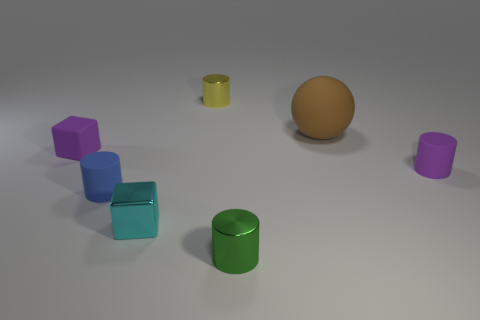Are there more brown matte objects than large cyan metal balls?
Your answer should be very brief. Yes. There is a cylinder that is in front of the tiny purple cube and behind the small blue object; how big is it?
Give a very brief answer. Small. What shape is the large thing?
Make the answer very short. Sphere. Is there anything else that is the same size as the purple cylinder?
Keep it short and to the point. Yes. Is the number of tiny blocks that are behind the tiny yellow metallic object greater than the number of small metal cylinders?
Your answer should be compact. No. What is the shape of the small rubber thing on the right side of the brown sphere that is right of the tiny purple rubber object left of the yellow metal object?
Offer a very short reply. Cylinder. There is a cylinder that is to the right of the green shiny cylinder; is its size the same as the purple block?
Provide a succinct answer. Yes. There is a small metallic object that is both right of the shiny cube and in front of the large rubber ball; what is its shape?
Ensure brevity in your answer.  Cylinder. There is a ball; is it the same color as the cube that is in front of the small blue thing?
Ensure brevity in your answer.  No. What is the color of the matte cylinder in front of the purple object on the right side of the metal cylinder in front of the large rubber thing?
Offer a very short reply. Blue. 